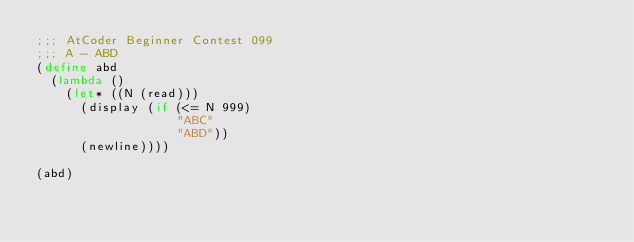Convert code to text. <code><loc_0><loc_0><loc_500><loc_500><_Scheme_>;;; AtCoder Beginner Contest 099
;;; A - ABD
(define abd
  (lambda ()
    (let* ((N (read)))
      (display (if (<= N 999)
                   "ABC"
                   "ABD"))
      (newline))))

(abd)
</code> 